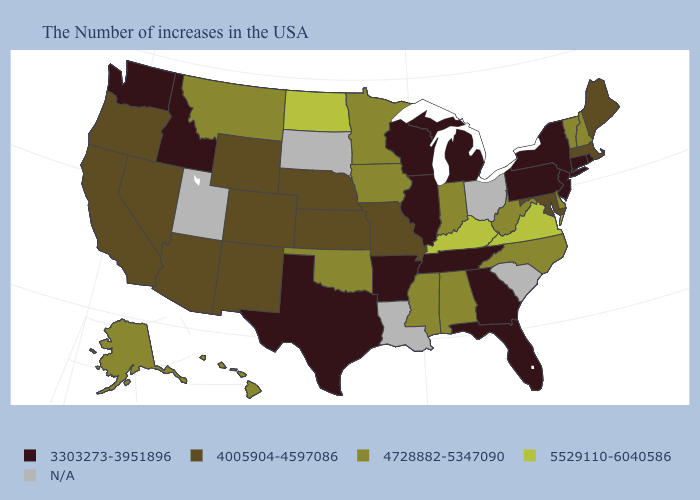Which states have the lowest value in the USA?
Give a very brief answer. Rhode Island, Connecticut, New York, New Jersey, Pennsylvania, Florida, Georgia, Michigan, Tennessee, Wisconsin, Illinois, Arkansas, Texas, Idaho, Washington. What is the value of Delaware?
Be succinct. 4728882-5347090. What is the highest value in states that border Connecticut?
Keep it brief. 4005904-4597086. Does the map have missing data?
Write a very short answer. Yes. Is the legend a continuous bar?
Answer briefly. No. Name the states that have a value in the range N/A?
Answer briefly. South Carolina, Ohio, Louisiana, South Dakota, Utah. Name the states that have a value in the range 5529110-6040586?
Write a very short answer. Virginia, Kentucky, North Dakota. What is the value of Wyoming?
Write a very short answer. 4005904-4597086. What is the value of Pennsylvania?
Keep it brief. 3303273-3951896. What is the highest value in the Northeast ?
Concise answer only. 4728882-5347090. Does Tennessee have the highest value in the USA?
Answer briefly. No. Does Washington have the lowest value in the USA?
Write a very short answer. Yes. Name the states that have a value in the range 5529110-6040586?
Quick response, please. Virginia, Kentucky, North Dakota. 